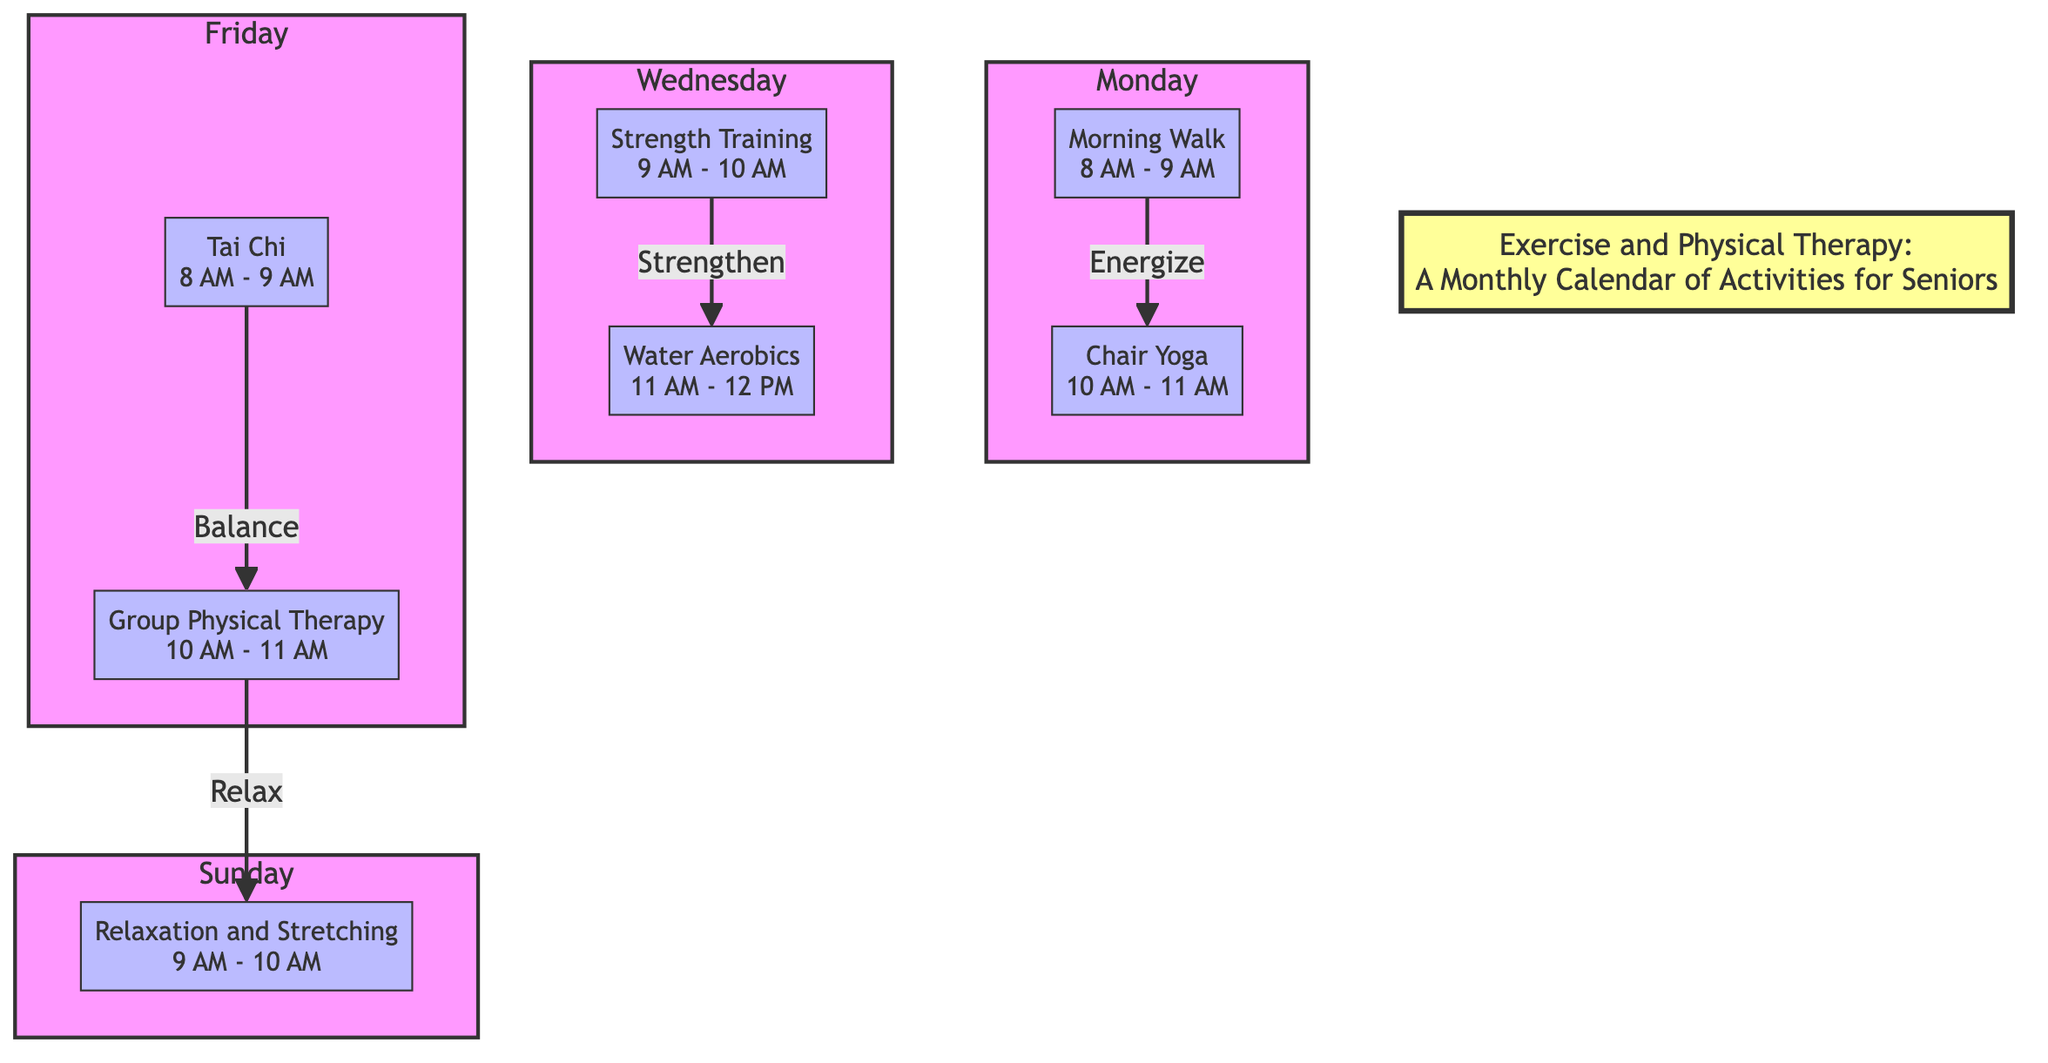What activities are scheduled for Monday? The diagram lists two activities scheduled for Monday: "Morning Walk" from 8 AM to 9 AM and "Chair Yoga" from 10 AM to 11 AM.
Answer: Morning Walk, Chair Yoga How many activities are there on Friday? Upon reviewing the diagram, there are two activities scheduled for Friday: "Tai Chi" and "Group Physical Therapy."
Answer: 2 What is the time for Water Aerobics on Wednesday? In the diagram, "Water Aerobics" is scheduled from 11 AM to 12 PM on Wednesday.
Answer: 11 AM - 12 PM Which activity follows Group Physical Therapy? The diagram shows that "Group Physical Therapy," scheduled for 10 AM to 11 AM on Friday, leads to "Relaxation and Stretching" scheduled for 9 AM to 10 AM on Sunday.
Answer: Relaxation and Stretching What is the purpose of the activity connection from Monday's Morning Walk to Chair Yoga? The diagram indicates that the connection between "Morning Walk" and "Chair Yoga" is labeled "Energize," suggesting that "Chair Yoga" follows after "Morning Walk" to continue energizing the participants.
Answer: Energize On which day is Strength Training scheduled? The diagram shows that "Strength Training" is scheduled on Wednesday from 9 AM to 10 AM.
Answer: Wednesday What is the earliest scheduled activity of the week? According to the diagram, the earliest activity of the week is "Morning Walk," which starts at 8 AM on Monday.
Answer: Morning Walk How many distinct days of activities are listed in the diagram? By examining the days mentioned in the diagram, we find activities listed for four distinct days: Monday, Wednesday, Friday, and Sunday.
Answer: 4 